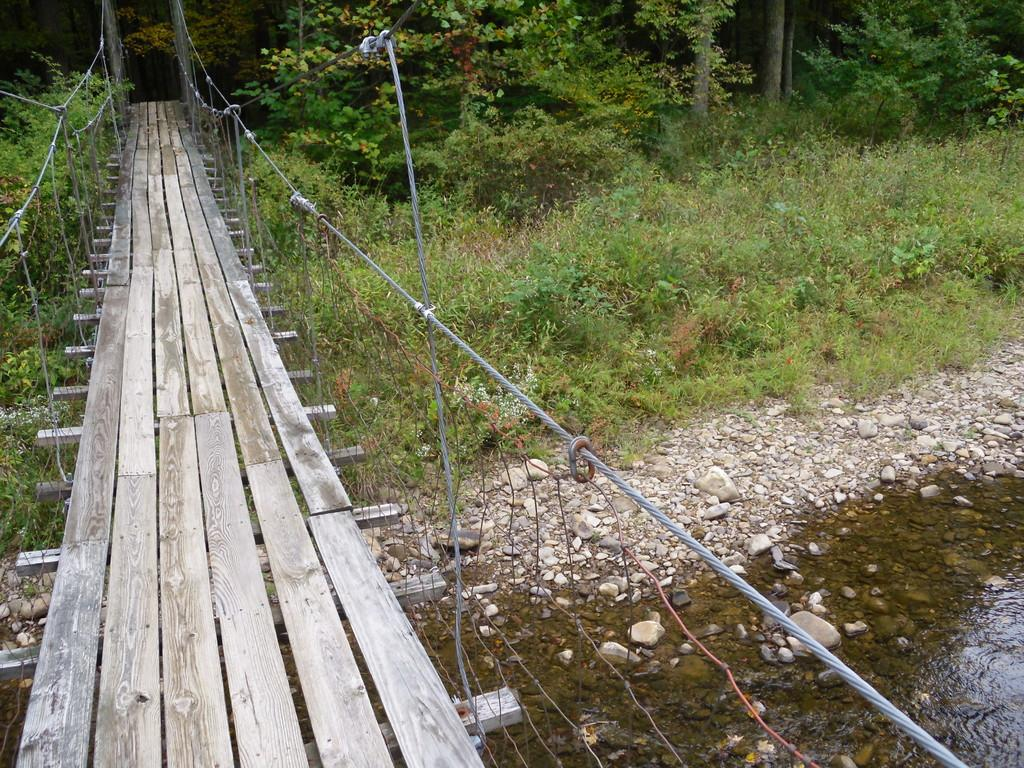What structure is located on the left side of the image? There is a bridge on the left side of the image. What can be seen at the right bottom of the image? There is water and stones at the right bottom of the image. What type of vegetation is in the background of the image? There are plants and trees in the background of the image. What type of waste can be seen in the image? There is no waste present in the image. What company is responsible for maintaining the bridge in the image? There is no information about a company responsible for maintaining the bridge in the image. 